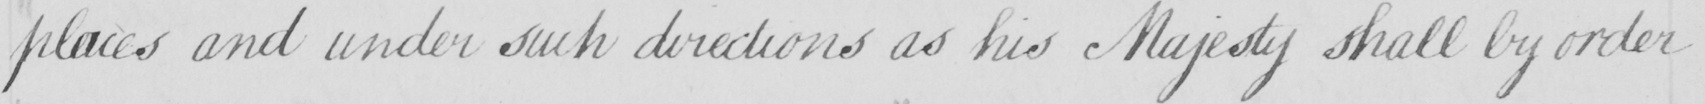Please transcribe the handwritten text in this image. places and under such directions as his Majesty shall by order 